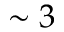<formula> <loc_0><loc_0><loc_500><loc_500>\sim 3</formula> 